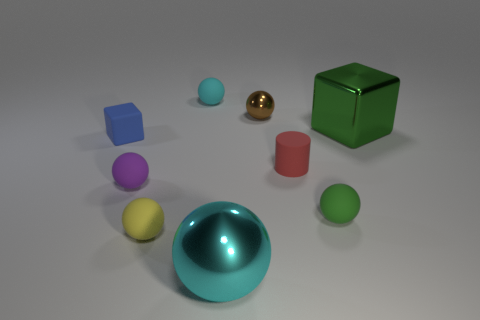The big cube is what color?
Offer a terse response. Green. Is the shape of the green object to the left of the large shiny cube the same as  the purple matte object?
Give a very brief answer. Yes. How many things are green rubber objects or large metallic things behind the tiny purple rubber object?
Provide a succinct answer. 2. Are the big object that is to the left of the brown ball and the tiny cyan thing made of the same material?
Your response must be concise. No. Is there any other thing that has the same size as the blue rubber block?
Offer a terse response. Yes. The cyan thing that is to the right of the rubber thing that is behind the tiny metallic thing is made of what material?
Your response must be concise. Metal. Is the number of tiny yellow things right of the large cyan object greater than the number of small blue things in front of the tiny blue rubber cube?
Your answer should be very brief. No. The shiny block is what size?
Keep it short and to the point. Large. Is the color of the matte object behind the green metal block the same as the big block?
Provide a short and direct response. No. Is there any other thing that is the same shape as the large green shiny thing?
Ensure brevity in your answer.  Yes. 